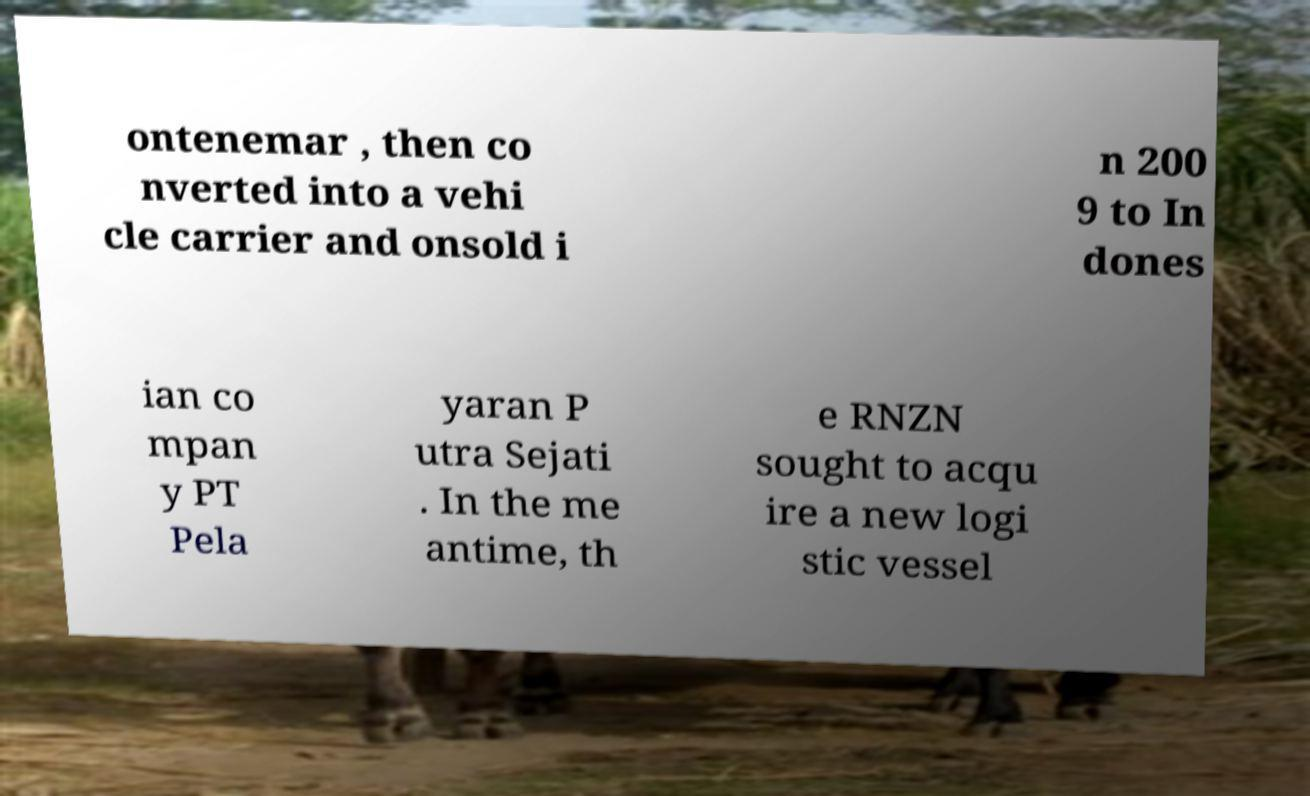Please read and relay the text visible in this image. What does it say? ontenemar , then co nverted into a vehi cle carrier and onsold i n 200 9 to In dones ian co mpan y PT Pela yaran P utra Sejati . In the me antime, th e RNZN sought to acqu ire a new logi stic vessel 